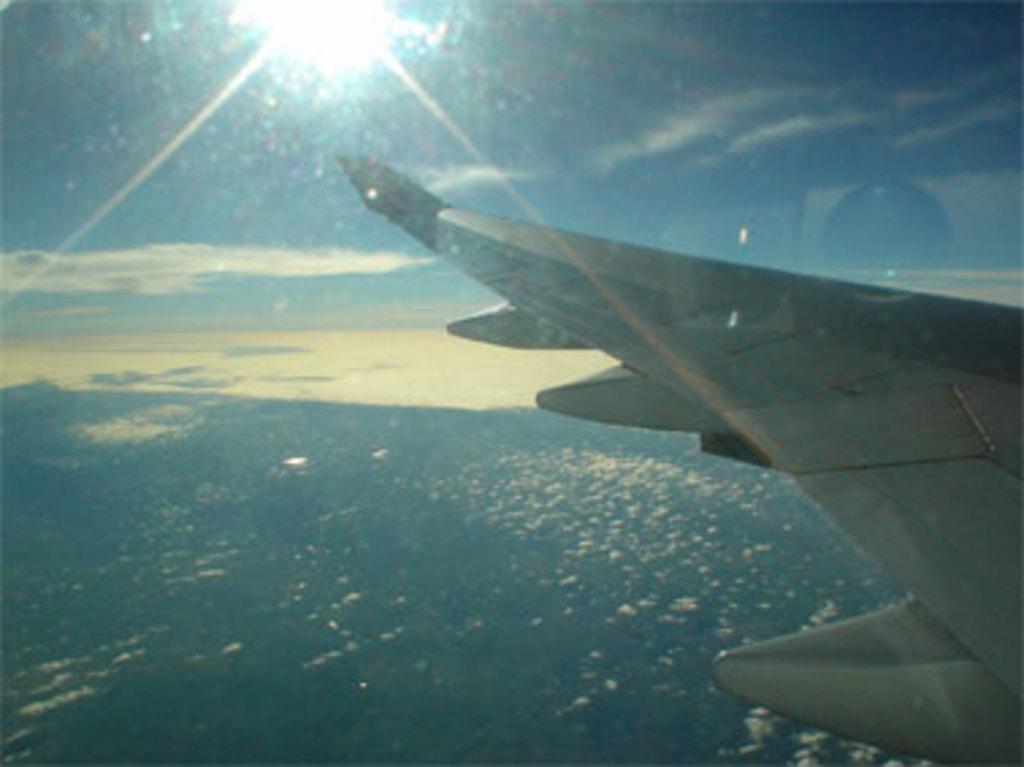Could you give a brief overview of what you see in this image? The image is taken from an airplane. In the foreground we can see wing of the airplane. At the bottom it is aerial view of city might be a forest. In the sky it is sun shining. 